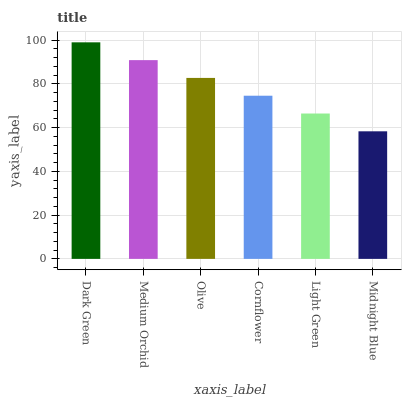Is Midnight Blue the minimum?
Answer yes or no. Yes. Is Dark Green the maximum?
Answer yes or no. Yes. Is Medium Orchid the minimum?
Answer yes or no. No. Is Medium Orchid the maximum?
Answer yes or no. No. Is Dark Green greater than Medium Orchid?
Answer yes or no. Yes. Is Medium Orchid less than Dark Green?
Answer yes or no. Yes. Is Medium Orchid greater than Dark Green?
Answer yes or no. No. Is Dark Green less than Medium Orchid?
Answer yes or no. No. Is Olive the high median?
Answer yes or no. Yes. Is Cornflower the low median?
Answer yes or no. Yes. Is Midnight Blue the high median?
Answer yes or no. No. Is Dark Green the low median?
Answer yes or no. No. 